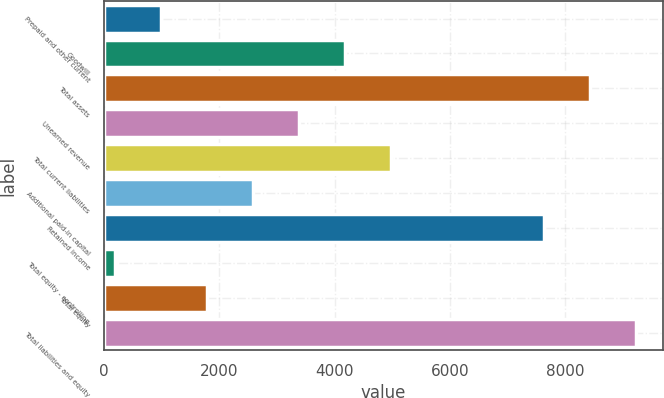<chart> <loc_0><loc_0><loc_500><loc_500><bar_chart><fcel>Prepaid and other current<fcel>Goodwill<fcel>Total assets<fcel>Unearned revenue<fcel>Total current liabilities<fcel>Additional paid-in capital<fcel>Retained income<fcel>Total equity - controlling<fcel>Total equity<fcel>Total liabilities and equity<nl><fcel>992.9<fcel>4188.5<fcel>8434.9<fcel>3389.6<fcel>4987.4<fcel>2590.7<fcel>7636<fcel>194<fcel>1791.8<fcel>9233.8<nl></chart> 